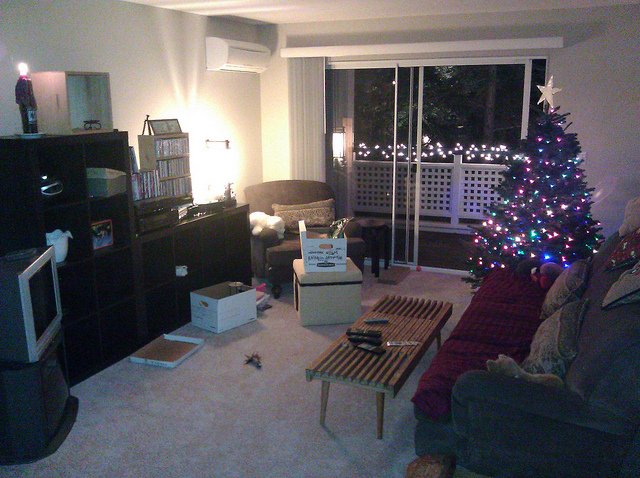<image>Is there an ac unit on this room? I'm not sure if there is an AC unit in the room. The answers are too ambiguous. Is there an ac unit on this room? I am not sure if there is an AC unit in this room. It can be both yes or no. 